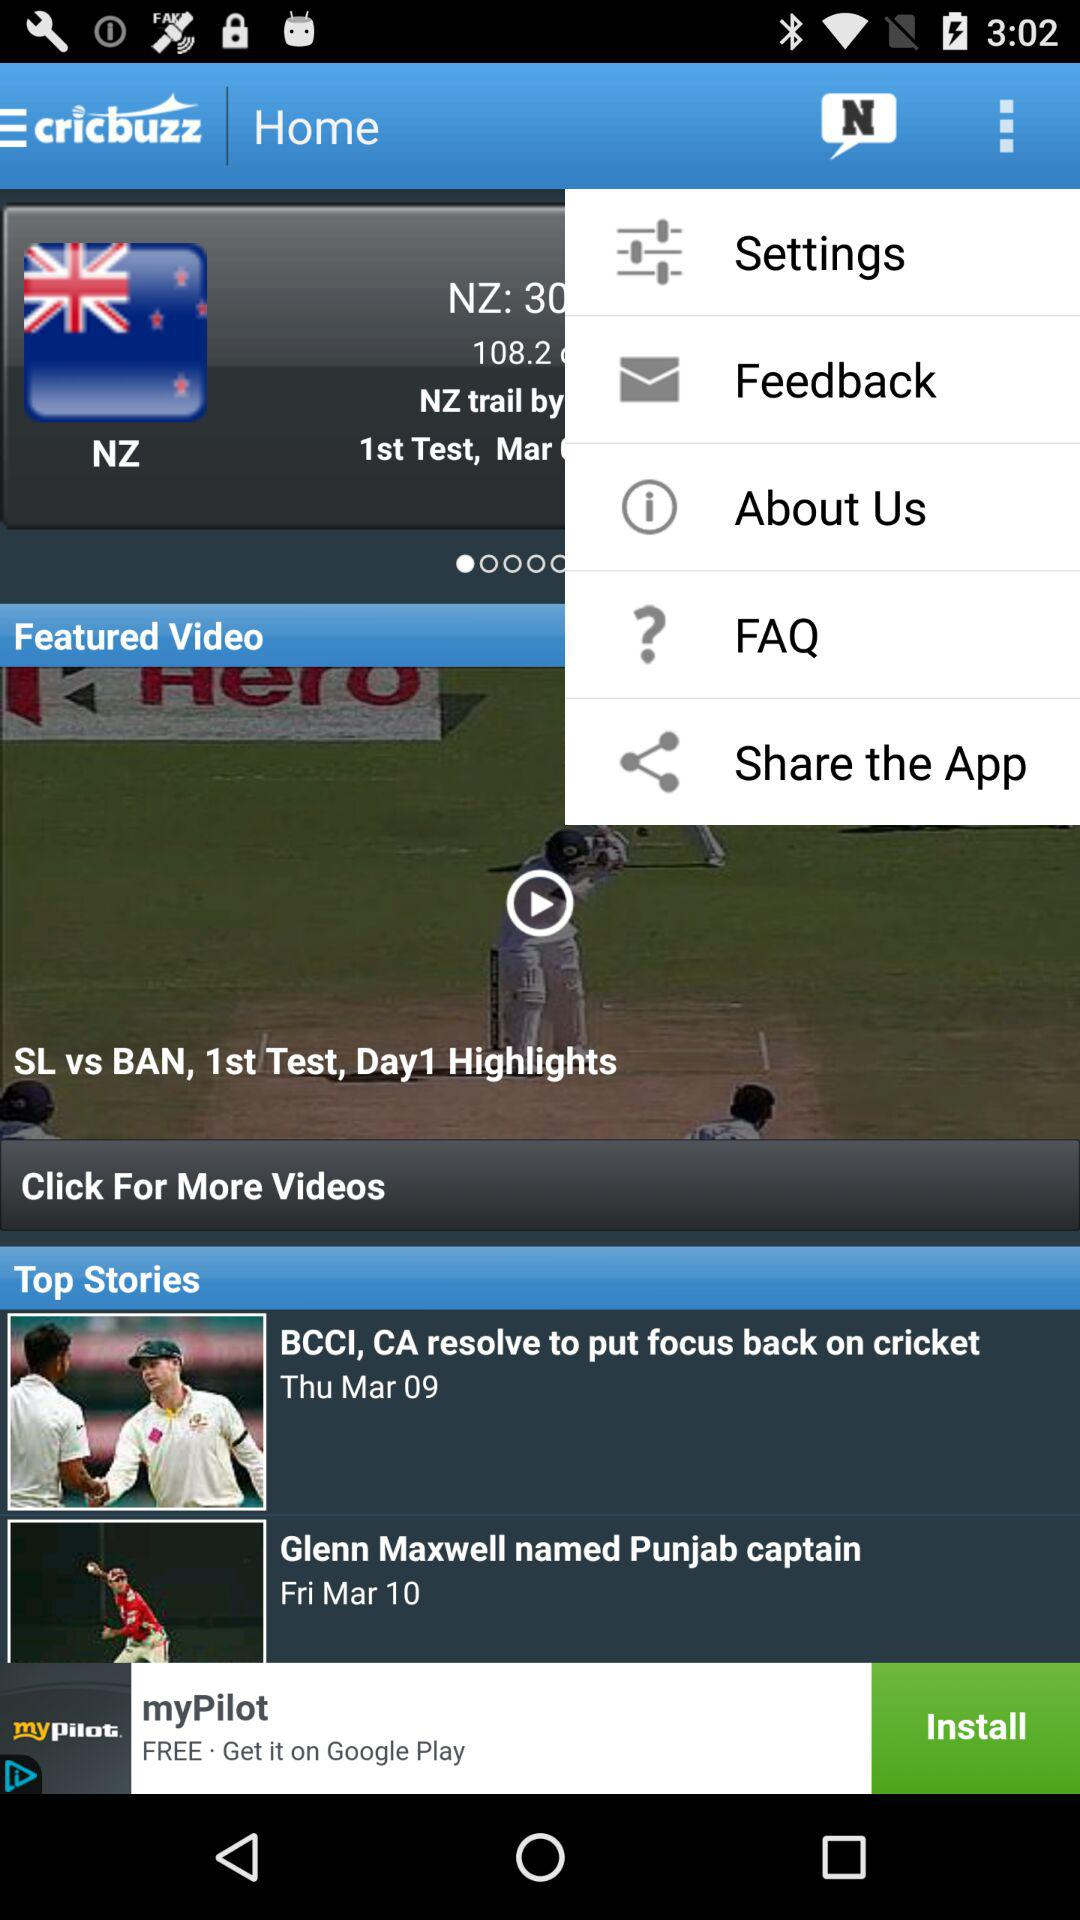How many more days are there between the two dates on the top stories section?
Answer the question using a single word or phrase. 1 